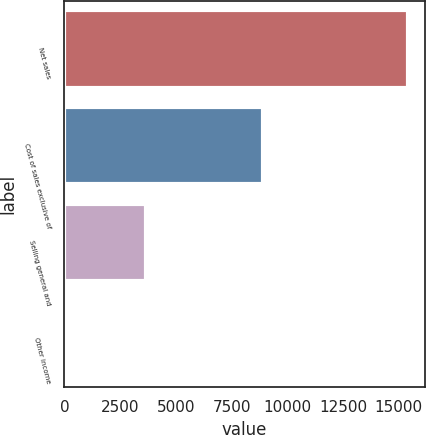<chart> <loc_0><loc_0><loc_500><loc_500><bar_chart><fcel>Net sales<fcel>Cost of sales exclusive of<fcel>Selling general and<fcel>Other income<nl><fcel>15399<fcel>8925<fcel>3682<fcel>122<nl></chart> 